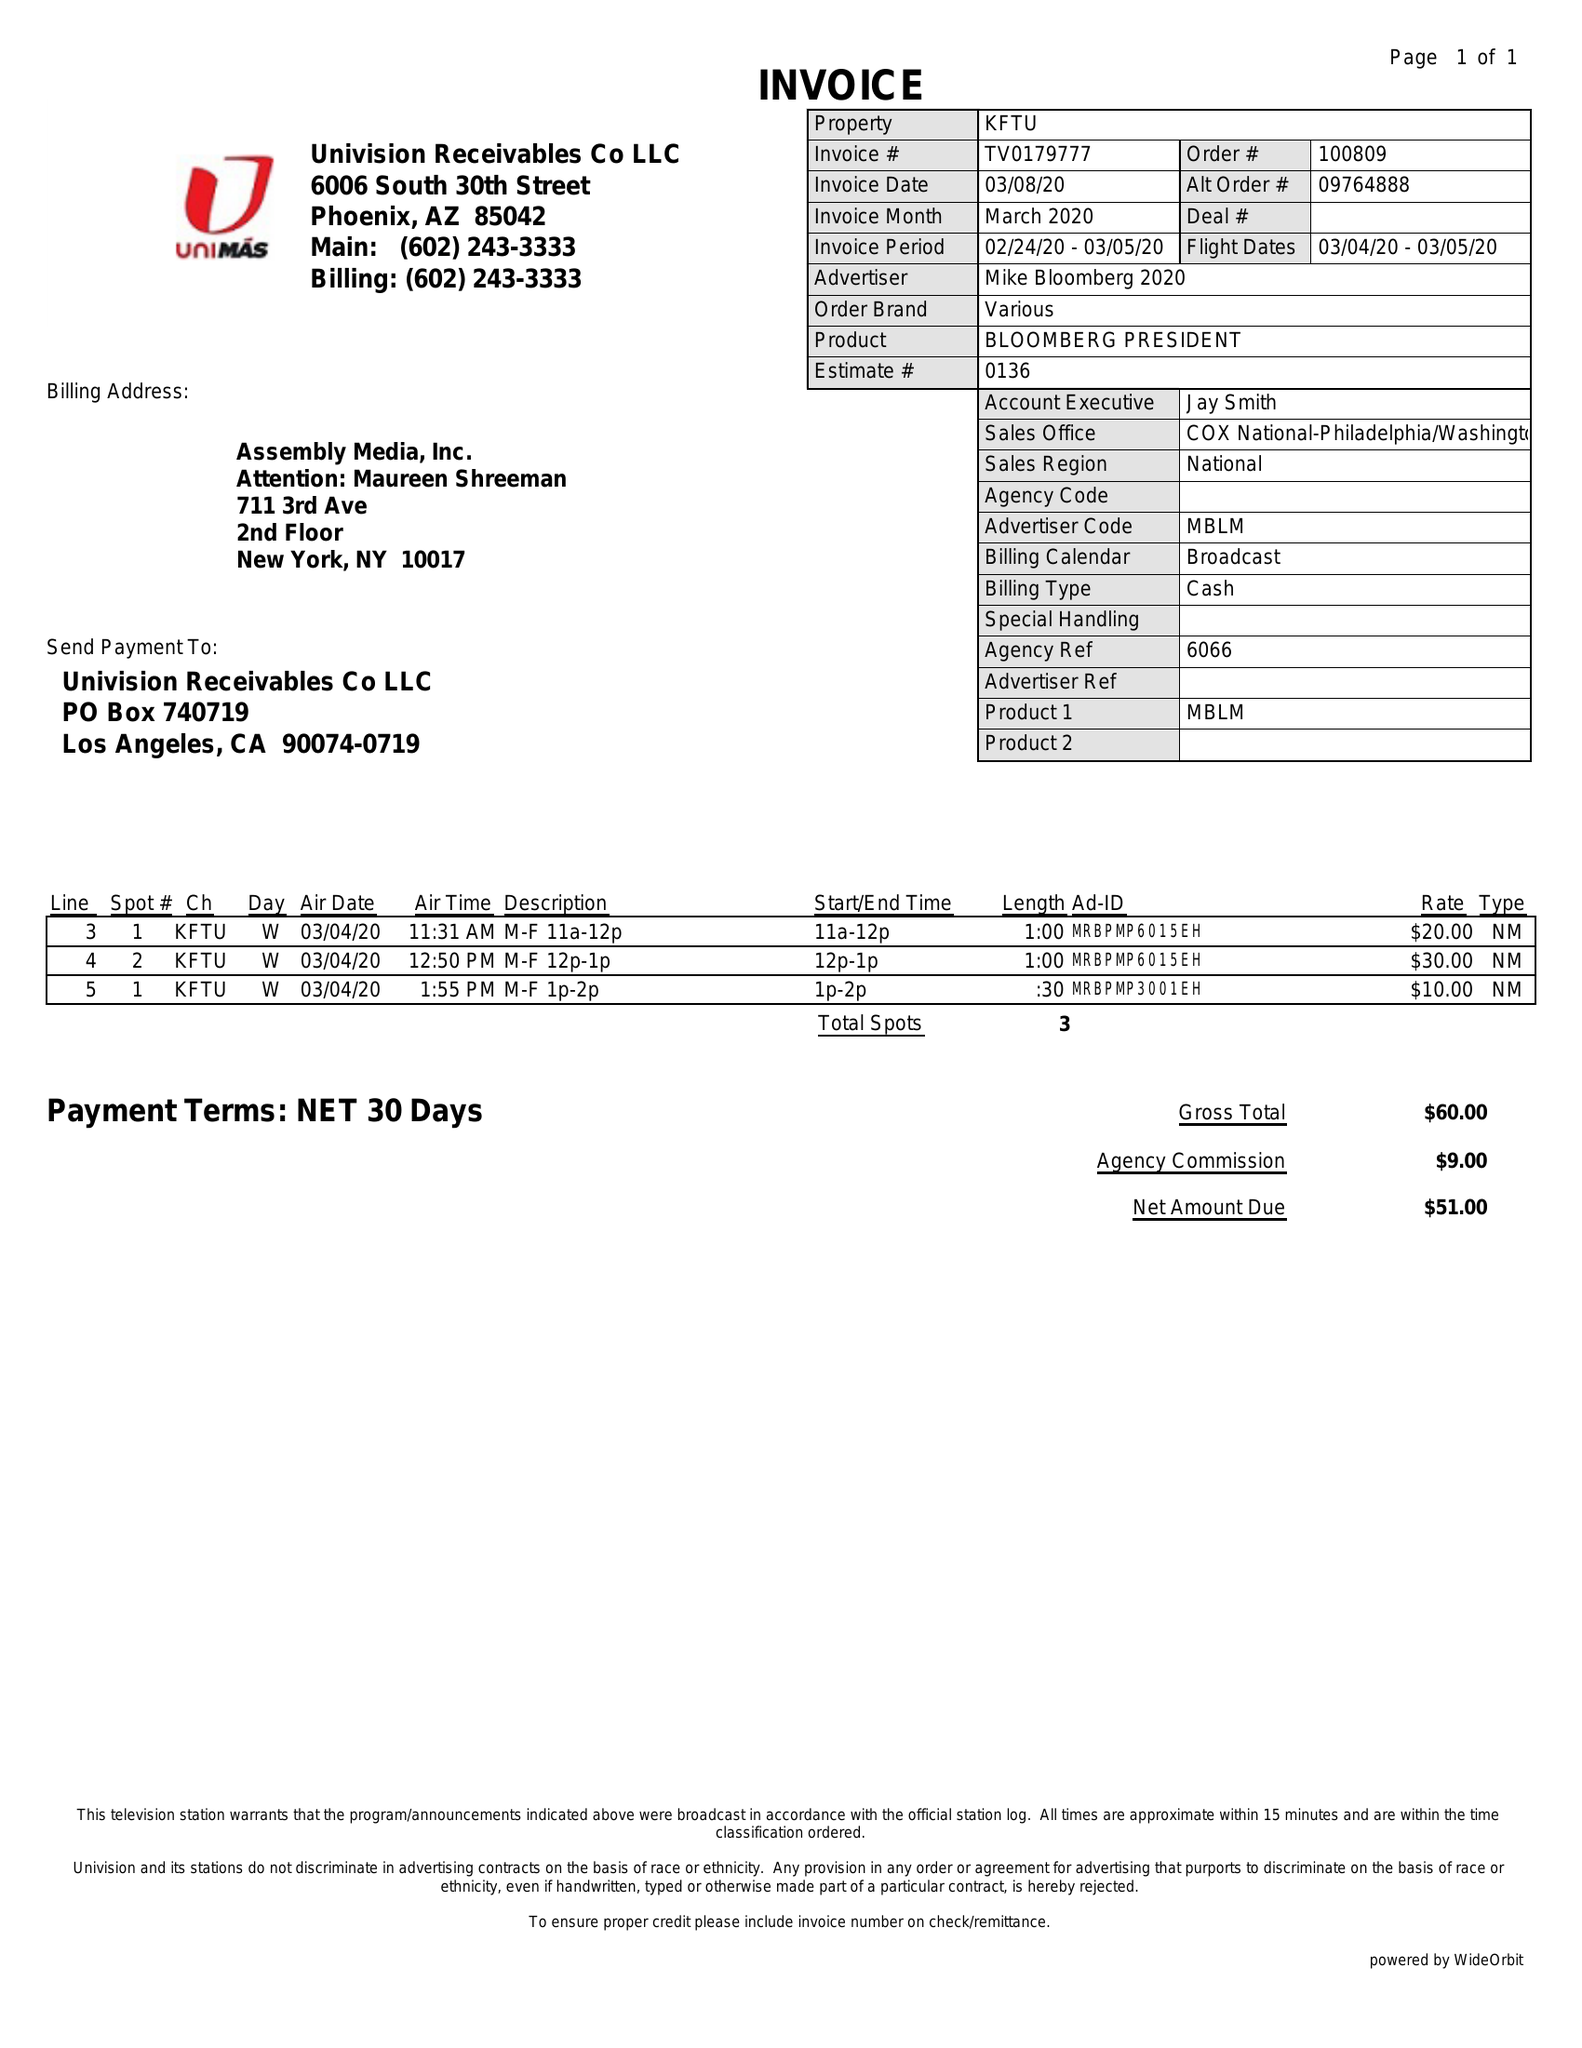What is the value for the flight_to?
Answer the question using a single word or phrase. 03/05/20 